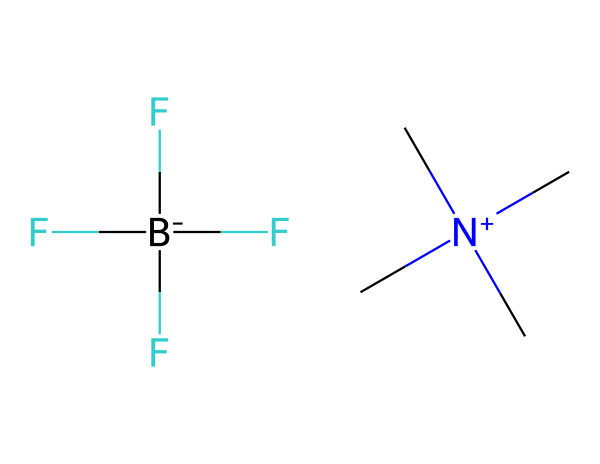What type of ions are present in this ionic liquid? The SMILES representation indicates a cation, which is the quaternary ammonium group containing nitrogen, and an anion, which is a tetrafluoroborate ion represented by BF4. Thus, the ionic liquid consists of these two types of ions.
Answer: cation and anion How many fluorine atoms are in the structure? Analyzing the SMILES, the tetrafluoroborate ion (BF4) contains four fluorine atoms. Therefore, there are a total of four fluorine atoms present in the chemical structure.
Answer: four What is the charge of the cation in this ionic liquid? The cation is created by the nitrogen atom in the quaternary ammonium, which carries a positive charge indicated by the notation [N+]. Thus, the cation has a positive charge.
Answer: positive What is the overall charge of this ionic liquid? The ionic liquid is composed of a positively charged cation and a negatively charged anion. Since the charges balance each other, the overall charge of the ionic liquid is neutral.
Answer: neutral What kind of properties can this ionic liquid provide in aromatherapy diffusers? Ionic liquids are known for their low volatility and ability to dissolve a wide range of compounds. This allows them to act effectively as solvents or carriers for essential oils in aromatherapy, enhancing the delivery of aromatic compounds into the air.
Answer: low volatility, solvent properties 